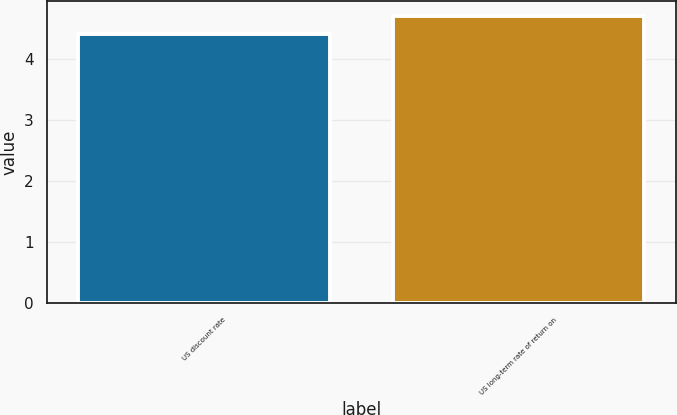Convert chart. <chart><loc_0><loc_0><loc_500><loc_500><bar_chart><fcel>US discount rate<fcel>US long-term rate of return on<nl><fcel>4.4<fcel>4.7<nl></chart> 